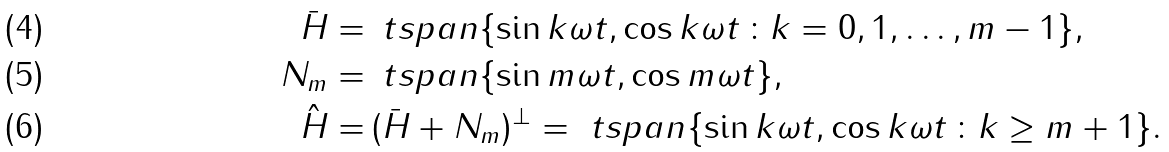Convert formula to latex. <formula><loc_0><loc_0><loc_500><loc_500>\ \bar { H } = & \, \ t { s p a n } \{ \sin k \omega t , \cos k \omega t \, \colon k = 0 , 1 , \dots , m - 1 \} , \\ \ N _ { m } = & \, \ t { s p a n } \{ \sin m \omega t , \cos m \omega t \} , \\ \ \hat { H } = & \, ( \bar { H } + N _ { m } ) ^ { \bot } = \ t { s p a n } \{ \sin k \omega t , \cos k \omega t \, \colon k \geq m + 1 \} .</formula> 